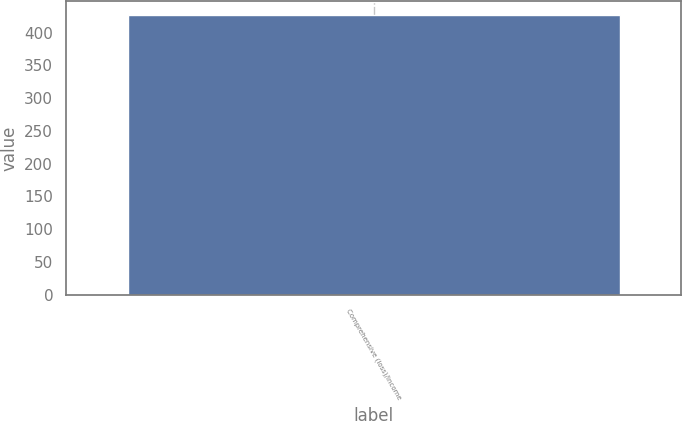Convert chart to OTSL. <chart><loc_0><loc_0><loc_500><loc_500><bar_chart><fcel>Comprehensive (loss)/income<nl><fcel>427<nl></chart> 